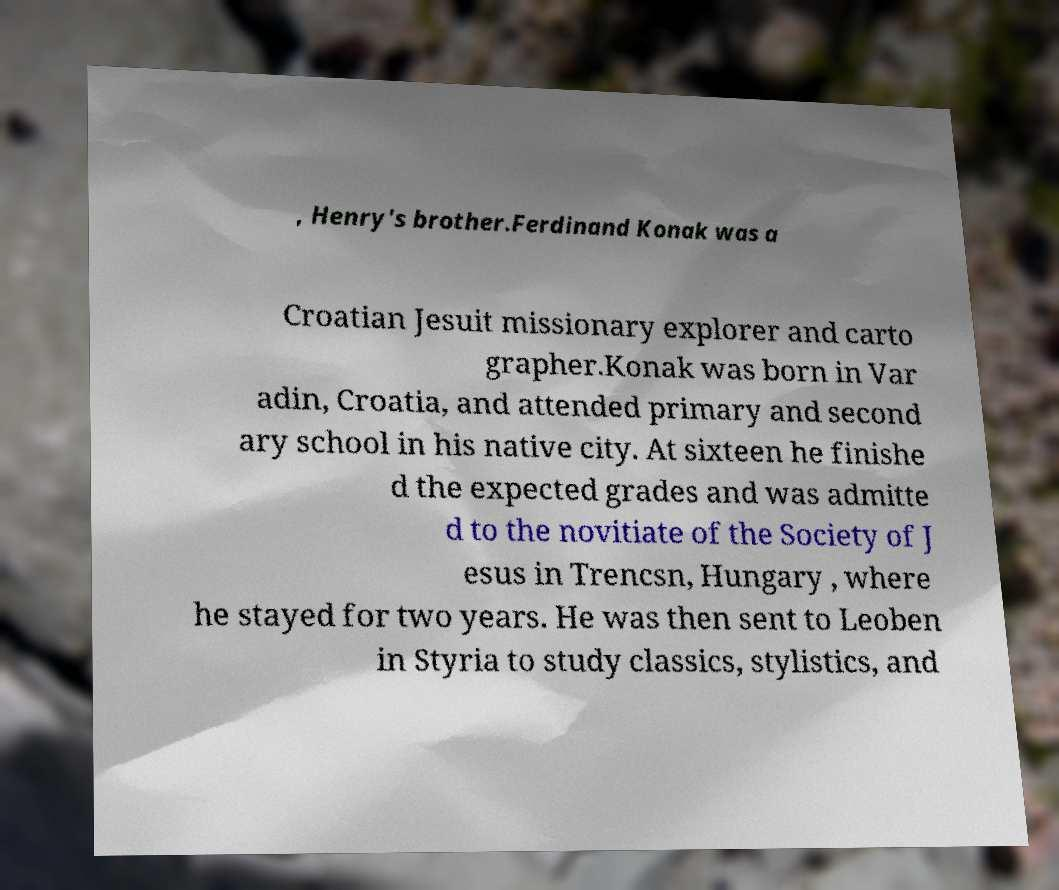What messages or text are displayed in this image? I need them in a readable, typed format. , Henry's brother.Ferdinand Konak was a Croatian Jesuit missionary explorer and carto grapher.Konak was born in Var adin, Croatia, and attended primary and second ary school in his native city. At sixteen he finishe d the expected grades and was admitte d to the novitiate of the Society of J esus in Trencsn, Hungary , where he stayed for two years. He was then sent to Leoben in Styria to study classics, stylistics, and 